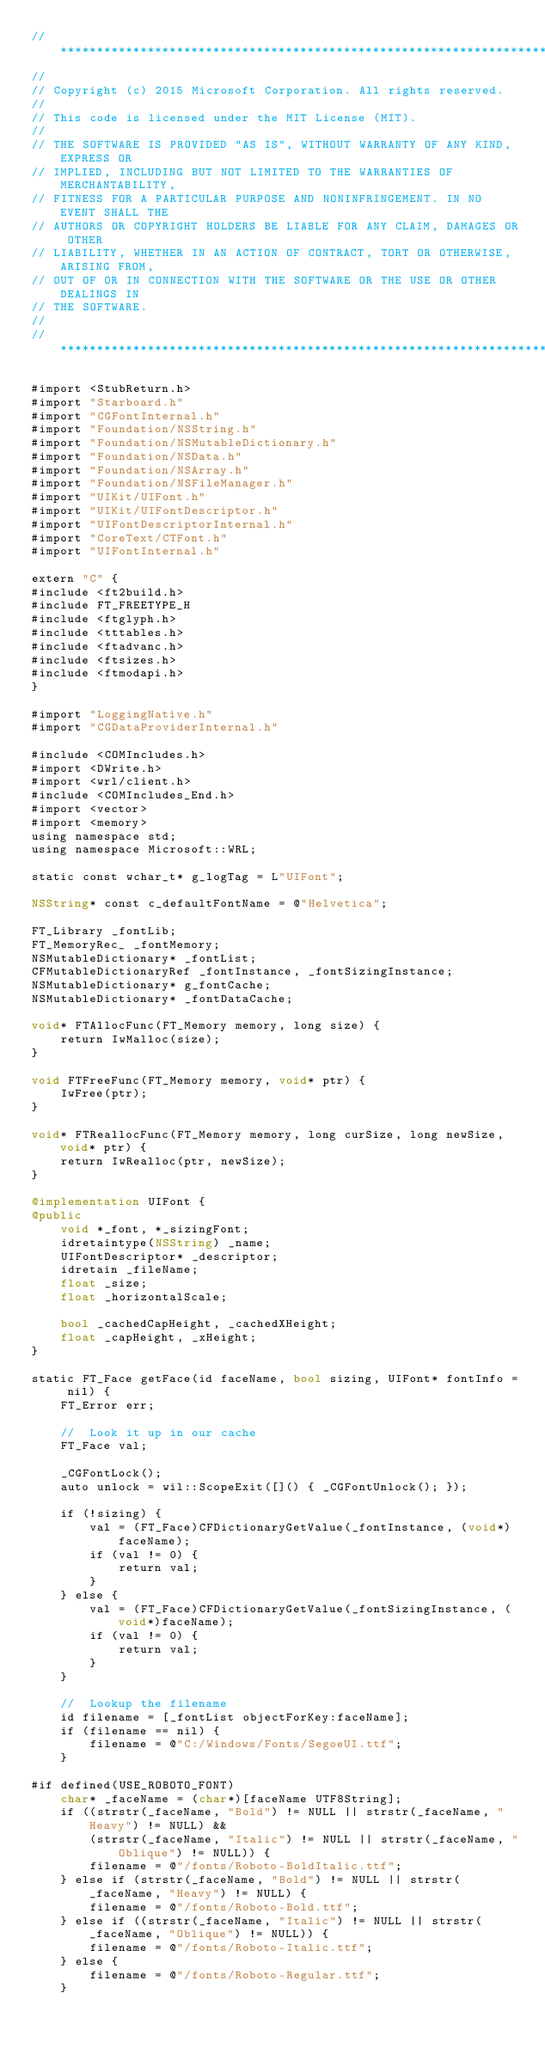<code> <loc_0><loc_0><loc_500><loc_500><_ObjectiveC_>//******************************************************************************
//
// Copyright (c) 2015 Microsoft Corporation. All rights reserved.
//
// This code is licensed under the MIT License (MIT).
//
// THE SOFTWARE IS PROVIDED "AS IS", WITHOUT WARRANTY OF ANY KIND, EXPRESS OR
// IMPLIED, INCLUDING BUT NOT LIMITED TO THE WARRANTIES OF MERCHANTABILITY,
// FITNESS FOR A PARTICULAR PURPOSE AND NONINFRINGEMENT. IN NO EVENT SHALL THE
// AUTHORS OR COPYRIGHT HOLDERS BE LIABLE FOR ANY CLAIM, DAMAGES OR OTHER
// LIABILITY, WHETHER IN AN ACTION OF CONTRACT, TORT OR OTHERWISE, ARISING FROM,
// OUT OF OR IN CONNECTION WITH THE SOFTWARE OR THE USE OR OTHER DEALINGS IN
// THE SOFTWARE.
//
//******************************************************************************

#import <StubReturn.h>
#import "Starboard.h"
#import "CGFontInternal.h"
#import "Foundation/NSString.h"
#import "Foundation/NSMutableDictionary.h"
#import "Foundation/NSData.h"
#import "Foundation/NSArray.h"
#import "Foundation/NSFileManager.h"
#import "UIKit/UIFont.h"
#import "UIKit/UIFontDescriptor.h"
#import "UIFontDescriptorInternal.h"
#import "CoreText/CTFont.h"
#import "UIFontInternal.h"

extern "C" {
#include <ft2build.h>
#include FT_FREETYPE_H
#include <ftglyph.h>
#include <tttables.h>
#include <ftadvanc.h>
#include <ftsizes.h>
#include <ftmodapi.h>
}

#import "LoggingNative.h"
#import "CGDataProviderInternal.h"

#include <COMIncludes.h>
#import <DWrite.h>
#import <wrl/client.h>
#include <COMIncludes_End.h>
#import <vector>
#import <memory>
using namespace std;
using namespace Microsoft::WRL;

static const wchar_t* g_logTag = L"UIFont";

NSString* const c_defaultFontName = @"Helvetica";

FT_Library _fontLib;
FT_MemoryRec_ _fontMemory;
NSMutableDictionary* _fontList;
CFMutableDictionaryRef _fontInstance, _fontSizingInstance;
NSMutableDictionary* g_fontCache;
NSMutableDictionary* _fontDataCache;

void* FTAllocFunc(FT_Memory memory, long size) {
    return IwMalloc(size);
}

void FTFreeFunc(FT_Memory memory, void* ptr) {
    IwFree(ptr);
}

void* FTReallocFunc(FT_Memory memory, long curSize, long newSize, void* ptr) {
    return IwRealloc(ptr, newSize);
}

@implementation UIFont {
@public
    void *_font, *_sizingFont;
    idretaintype(NSString) _name;
    UIFontDescriptor* _descriptor;
    idretain _fileName;
    float _size;
    float _horizontalScale;

    bool _cachedCapHeight, _cachedXHeight;
    float _capHeight, _xHeight;
}

static FT_Face getFace(id faceName, bool sizing, UIFont* fontInfo = nil) {
    FT_Error err;

    //  Look it up in our cache
    FT_Face val;

    _CGFontLock();
    auto unlock = wil::ScopeExit([]() { _CGFontUnlock(); });

    if (!sizing) {
        val = (FT_Face)CFDictionaryGetValue(_fontInstance, (void*)faceName);
        if (val != 0) {
            return val;
        }
    } else {
        val = (FT_Face)CFDictionaryGetValue(_fontSizingInstance, (void*)faceName);
        if (val != 0) {
            return val;
        }
    }

    //  Lookup the filename
    id filename = [_fontList objectForKey:faceName];
    if (filename == nil) {
        filename = @"C:/Windows/Fonts/SegoeUI.ttf";
    }

#if defined(USE_ROBOTO_FONT)
    char* _faceName = (char*)[faceName UTF8String];
    if ((strstr(_faceName, "Bold") != NULL || strstr(_faceName, "Heavy") != NULL) &&
        (strstr(_faceName, "Italic") != NULL || strstr(_faceName, "Oblique") != NULL)) {
        filename = @"/fonts/Roboto-BoldItalic.ttf";
    } else if (strstr(_faceName, "Bold") != NULL || strstr(_faceName, "Heavy") != NULL) {
        filename = @"/fonts/Roboto-Bold.ttf";
    } else if ((strstr(_faceName, "Italic") != NULL || strstr(_faceName, "Oblique") != NULL)) {
        filename = @"/fonts/Roboto-Italic.ttf";
    } else {
        filename = @"/fonts/Roboto-Regular.ttf";
    }
</code> 